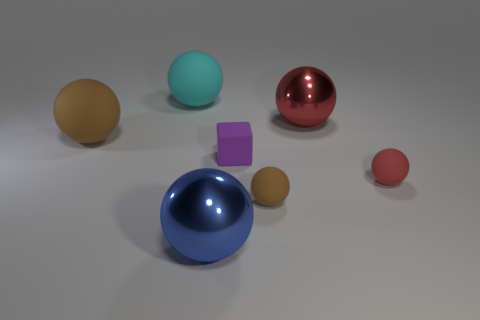What number of red things are either large balls or small cubes?
Offer a terse response. 1. What number of other cyan matte spheres are the same size as the cyan rubber ball?
Provide a succinct answer. 0. How many objects are tiny metallic balls or big metal things in front of the tiny brown thing?
Give a very brief answer. 1. There is a brown object on the left side of the blue thing; is it the same size as the red ball in front of the large brown rubber object?
Provide a short and direct response. No. What number of tiny brown objects have the same shape as the red shiny thing?
Ensure brevity in your answer.  1. What is the shape of the big cyan thing that is the same material as the tiny purple object?
Give a very brief answer. Sphere. What is the thing that is to the left of the large rubber sphere behind the shiny ball on the right side of the blue object made of?
Provide a short and direct response. Rubber. There is a purple rubber thing; is its size the same as the object behind the large red metallic object?
Your answer should be compact. No. There is a blue thing that is the same shape as the large cyan object; what is it made of?
Make the answer very short. Metal. There is a object on the left side of the ball behind the big metal ball that is behind the blue object; how big is it?
Provide a succinct answer. Large. 